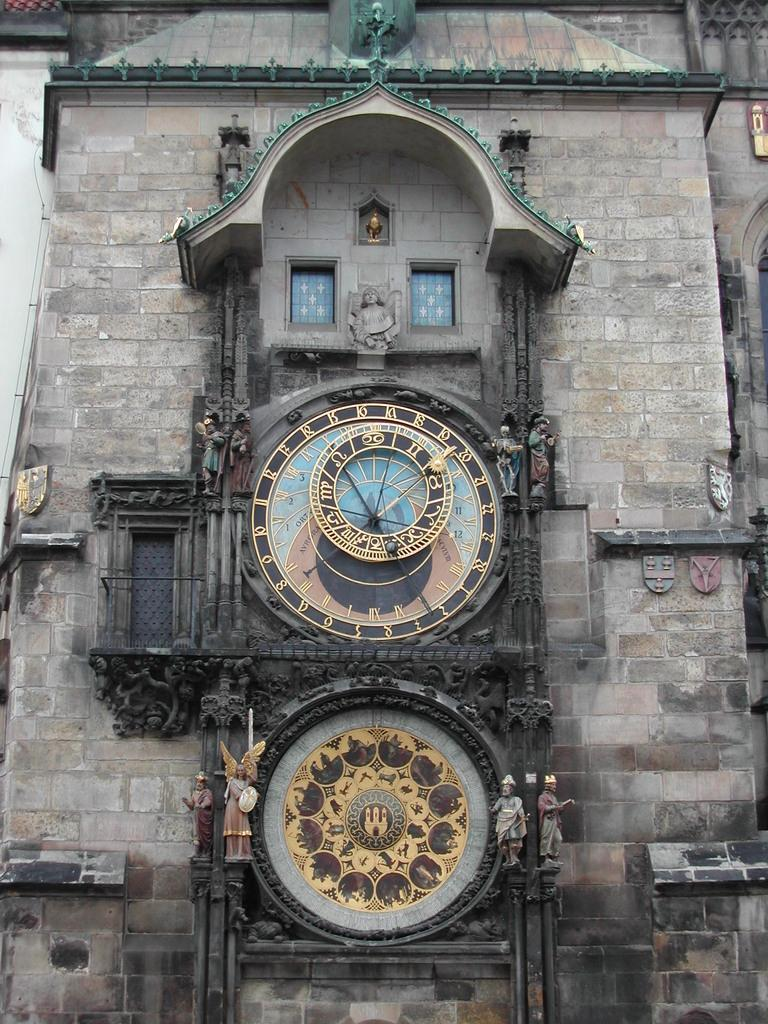Provide a one-sentence caption for the provided image. A strange and complicated clock features the numbers 16 and 18 near the top of the face. 